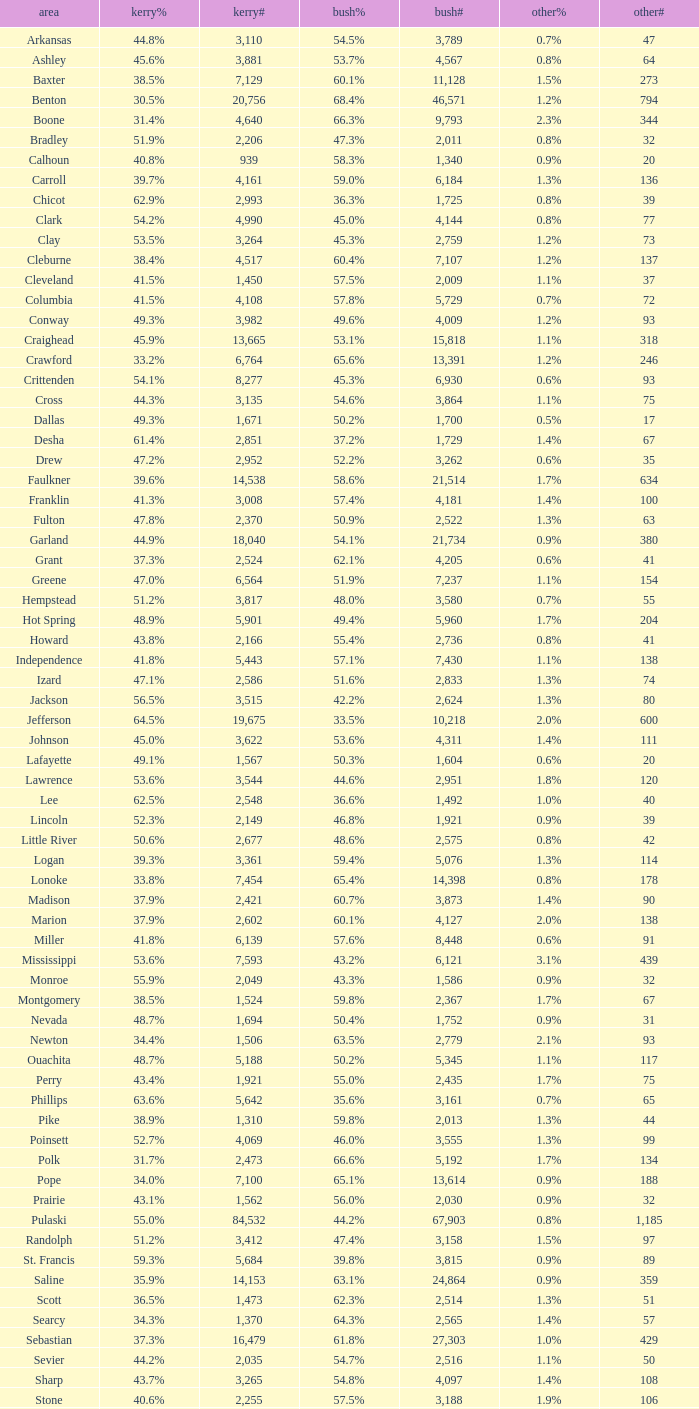4%"? 14398.0. 